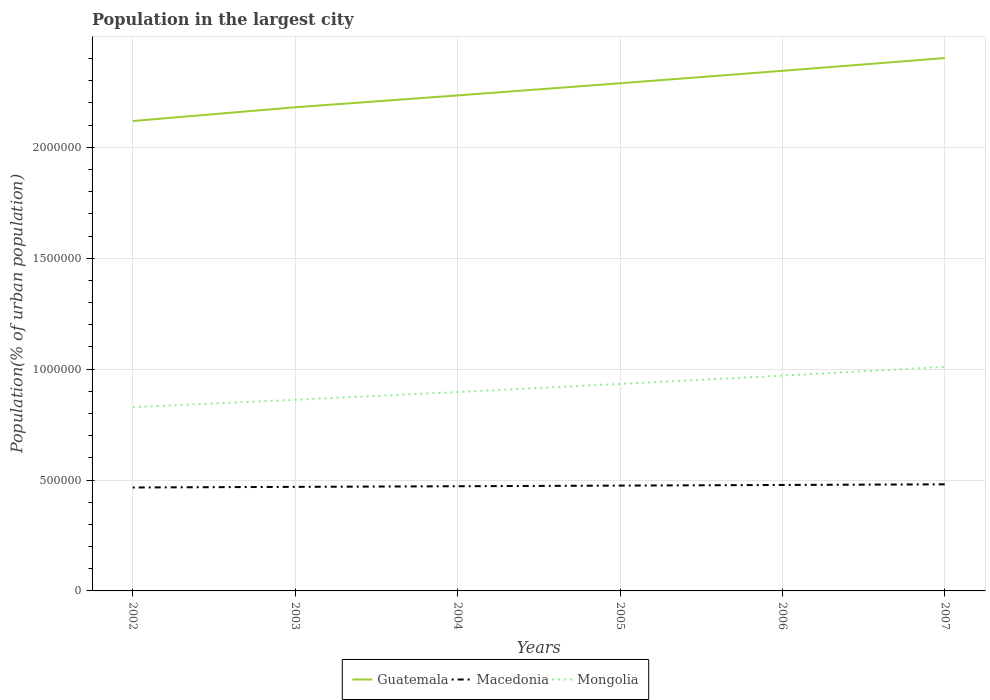Is the number of lines equal to the number of legend labels?
Your response must be concise. Yes. Across all years, what is the maximum population in the largest city in Mongolia?
Ensure brevity in your answer.  8.28e+05. In which year was the population in the largest city in Mongolia maximum?
Your response must be concise. 2002. What is the total population in the largest city in Mongolia in the graph?
Your response must be concise. -1.48e+05. What is the difference between the highest and the second highest population in the largest city in Guatemala?
Offer a terse response. 2.84e+05. What is the difference between the highest and the lowest population in the largest city in Mongolia?
Your answer should be compact. 3. Is the population in the largest city in Mongolia strictly greater than the population in the largest city in Macedonia over the years?
Give a very brief answer. No. How many years are there in the graph?
Your response must be concise. 6. What is the difference between two consecutive major ticks on the Y-axis?
Provide a succinct answer. 5.00e+05. Where does the legend appear in the graph?
Keep it short and to the point. Bottom center. What is the title of the graph?
Your response must be concise. Population in the largest city. What is the label or title of the X-axis?
Offer a terse response. Years. What is the label or title of the Y-axis?
Offer a very short reply. Population(% of urban population). What is the Population(% of urban population) in Guatemala in 2002?
Your response must be concise. 2.12e+06. What is the Population(% of urban population) in Macedonia in 2002?
Ensure brevity in your answer.  4.66e+05. What is the Population(% of urban population) in Mongolia in 2002?
Provide a short and direct response. 8.28e+05. What is the Population(% of urban population) in Guatemala in 2003?
Your answer should be very brief. 2.18e+06. What is the Population(% of urban population) of Macedonia in 2003?
Offer a terse response. 4.69e+05. What is the Population(% of urban population) in Mongolia in 2003?
Offer a very short reply. 8.62e+05. What is the Population(% of urban population) in Guatemala in 2004?
Your response must be concise. 2.23e+06. What is the Population(% of urban population) in Macedonia in 2004?
Give a very brief answer. 4.72e+05. What is the Population(% of urban population) in Mongolia in 2004?
Provide a short and direct response. 8.97e+05. What is the Population(% of urban population) in Guatemala in 2005?
Make the answer very short. 2.29e+06. What is the Population(% of urban population) of Macedonia in 2005?
Make the answer very short. 4.75e+05. What is the Population(% of urban population) of Mongolia in 2005?
Provide a short and direct response. 9.33e+05. What is the Population(% of urban population) of Guatemala in 2006?
Make the answer very short. 2.34e+06. What is the Population(% of urban population) in Macedonia in 2006?
Your response must be concise. 4.78e+05. What is the Population(% of urban population) in Mongolia in 2006?
Give a very brief answer. 9.71e+05. What is the Population(% of urban population) in Guatemala in 2007?
Provide a short and direct response. 2.40e+06. What is the Population(% of urban population) of Macedonia in 2007?
Make the answer very short. 4.81e+05. What is the Population(% of urban population) of Mongolia in 2007?
Keep it short and to the point. 1.01e+06. Across all years, what is the maximum Population(% of urban population) in Guatemala?
Offer a terse response. 2.40e+06. Across all years, what is the maximum Population(% of urban population) of Macedonia?
Your answer should be compact. 4.81e+05. Across all years, what is the maximum Population(% of urban population) of Mongolia?
Provide a succinct answer. 1.01e+06. Across all years, what is the minimum Population(% of urban population) in Guatemala?
Offer a very short reply. 2.12e+06. Across all years, what is the minimum Population(% of urban population) in Macedonia?
Your response must be concise. 4.66e+05. Across all years, what is the minimum Population(% of urban population) in Mongolia?
Keep it short and to the point. 8.28e+05. What is the total Population(% of urban population) of Guatemala in the graph?
Your answer should be very brief. 1.36e+07. What is the total Population(% of urban population) in Macedonia in the graph?
Offer a terse response. 2.84e+06. What is the total Population(% of urban population) of Mongolia in the graph?
Your answer should be very brief. 5.50e+06. What is the difference between the Population(% of urban population) in Guatemala in 2002 and that in 2003?
Provide a succinct answer. -6.19e+04. What is the difference between the Population(% of urban population) of Macedonia in 2002 and that in 2003?
Offer a very short reply. -2819. What is the difference between the Population(% of urban population) of Mongolia in 2002 and that in 2003?
Your answer should be compact. -3.35e+04. What is the difference between the Population(% of urban population) of Guatemala in 2002 and that in 2004?
Your answer should be very brief. -1.15e+05. What is the difference between the Population(% of urban population) of Macedonia in 2002 and that in 2004?
Offer a terse response. -5655. What is the difference between the Population(% of urban population) of Mongolia in 2002 and that in 2004?
Make the answer very short. -6.85e+04. What is the difference between the Population(% of urban population) of Guatemala in 2002 and that in 2005?
Your response must be concise. -1.70e+05. What is the difference between the Population(% of urban population) of Macedonia in 2002 and that in 2005?
Offer a terse response. -8508. What is the difference between the Population(% of urban population) in Mongolia in 2002 and that in 2005?
Your response must be concise. -1.05e+05. What is the difference between the Population(% of urban population) of Guatemala in 2002 and that in 2006?
Give a very brief answer. -2.26e+05. What is the difference between the Population(% of urban population) in Macedonia in 2002 and that in 2006?
Ensure brevity in your answer.  -1.14e+04. What is the difference between the Population(% of urban population) in Mongolia in 2002 and that in 2006?
Ensure brevity in your answer.  -1.43e+05. What is the difference between the Population(% of urban population) of Guatemala in 2002 and that in 2007?
Your answer should be very brief. -2.84e+05. What is the difference between the Population(% of urban population) in Macedonia in 2002 and that in 2007?
Your answer should be very brief. -1.43e+04. What is the difference between the Population(% of urban population) in Mongolia in 2002 and that in 2007?
Ensure brevity in your answer.  -1.82e+05. What is the difference between the Population(% of urban population) of Guatemala in 2003 and that in 2004?
Your answer should be very brief. -5.36e+04. What is the difference between the Population(% of urban population) of Macedonia in 2003 and that in 2004?
Make the answer very short. -2836. What is the difference between the Population(% of urban population) of Mongolia in 2003 and that in 2004?
Your response must be concise. -3.49e+04. What is the difference between the Population(% of urban population) of Guatemala in 2003 and that in 2005?
Keep it short and to the point. -1.08e+05. What is the difference between the Population(% of urban population) of Macedonia in 2003 and that in 2005?
Your answer should be compact. -5689. What is the difference between the Population(% of urban population) of Mongolia in 2003 and that in 2005?
Offer a very short reply. -7.12e+04. What is the difference between the Population(% of urban population) in Guatemala in 2003 and that in 2006?
Offer a very short reply. -1.64e+05. What is the difference between the Population(% of urban population) in Macedonia in 2003 and that in 2006?
Offer a terse response. -8560. What is the difference between the Population(% of urban population) in Mongolia in 2003 and that in 2006?
Provide a short and direct response. -1.09e+05. What is the difference between the Population(% of urban population) in Guatemala in 2003 and that in 2007?
Give a very brief answer. -2.22e+05. What is the difference between the Population(% of urban population) in Macedonia in 2003 and that in 2007?
Make the answer very short. -1.14e+04. What is the difference between the Population(% of urban population) in Mongolia in 2003 and that in 2007?
Offer a very short reply. -1.48e+05. What is the difference between the Population(% of urban population) of Guatemala in 2004 and that in 2005?
Give a very brief answer. -5.47e+04. What is the difference between the Population(% of urban population) in Macedonia in 2004 and that in 2005?
Provide a short and direct response. -2853. What is the difference between the Population(% of urban population) in Mongolia in 2004 and that in 2005?
Offer a terse response. -3.63e+04. What is the difference between the Population(% of urban population) of Guatemala in 2004 and that in 2006?
Your response must be concise. -1.11e+05. What is the difference between the Population(% of urban population) of Macedonia in 2004 and that in 2006?
Offer a very short reply. -5724. What is the difference between the Population(% of urban population) of Mongolia in 2004 and that in 2006?
Provide a short and direct response. -7.40e+04. What is the difference between the Population(% of urban population) in Guatemala in 2004 and that in 2007?
Offer a terse response. -1.68e+05. What is the difference between the Population(% of urban population) of Macedonia in 2004 and that in 2007?
Keep it short and to the point. -8611. What is the difference between the Population(% of urban population) of Mongolia in 2004 and that in 2007?
Ensure brevity in your answer.  -1.13e+05. What is the difference between the Population(% of urban population) in Guatemala in 2005 and that in 2006?
Your answer should be very brief. -5.62e+04. What is the difference between the Population(% of urban population) in Macedonia in 2005 and that in 2006?
Provide a succinct answer. -2871. What is the difference between the Population(% of urban population) of Mongolia in 2005 and that in 2006?
Provide a succinct answer. -3.78e+04. What is the difference between the Population(% of urban population) of Guatemala in 2005 and that in 2007?
Provide a short and direct response. -1.14e+05. What is the difference between the Population(% of urban population) in Macedonia in 2005 and that in 2007?
Provide a succinct answer. -5758. What is the difference between the Population(% of urban population) of Mongolia in 2005 and that in 2007?
Provide a short and direct response. -7.71e+04. What is the difference between the Population(% of urban population) in Guatemala in 2006 and that in 2007?
Keep it short and to the point. -5.75e+04. What is the difference between the Population(% of urban population) in Macedonia in 2006 and that in 2007?
Keep it short and to the point. -2887. What is the difference between the Population(% of urban population) in Mongolia in 2006 and that in 2007?
Provide a succinct answer. -3.93e+04. What is the difference between the Population(% of urban population) of Guatemala in 2002 and the Population(% of urban population) of Macedonia in 2003?
Provide a succinct answer. 1.65e+06. What is the difference between the Population(% of urban population) in Guatemala in 2002 and the Population(% of urban population) in Mongolia in 2003?
Provide a succinct answer. 1.26e+06. What is the difference between the Population(% of urban population) of Macedonia in 2002 and the Population(% of urban population) of Mongolia in 2003?
Keep it short and to the point. -3.95e+05. What is the difference between the Population(% of urban population) in Guatemala in 2002 and the Population(% of urban population) in Macedonia in 2004?
Your response must be concise. 1.65e+06. What is the difference between the Population(% of urban population) in Guatemala in 2002 and the Population(% of urban population) in Mongolia in 2004?
Offer a very short reply. 1.22e+06. What is the difference between the Population(% of urban population) of Macedonia in 2002 and the Population(% of urban population) of Mongolia in 2004?
Your response must be concise. -4.30e+05. What is the difference between the Population(% of urban population) in Guatemala in 2002 and the Population(% of urban population) in Macedonia in 2005?
Give a very brief answer. 1.64e+06. What is the difference between the Population(% of urban population) of Guatemala in 2002 and the Population(% of urban population) of Mongolia in 2005?
Keep it short and to the point. 1.19e+06. What is the difference between the Population(% of urban population) of Macedonia in 2002 and the Population(% of urban population) of Mongolia in 2005?
Provide a succinct answer. -4.67e+05. What is the difference between the Population(% of urban population) of Guatemala in 2002 and the Population(% of urban population) of Macedonia in 2006?
Ensure brevity in your answer.  1.64e+06. What is the difference between the Population(% of urban population) of Guatemala in 2002 and the Population(% of urban population) of Mongolia in 2006?
Provide a short and direct response. 1.15e+06. What is the difference between the Population(% of urban population) in Macedonia in 2002 and the Population(% of urban population) in Mongolia in 2006?
Make the answer very short. -5.04e+05. What is the difference between the Population(% of urban population) of Guatemala in 2002 and the Population(% of urban population) of Macedonia in 2007?
Your response must be concise. 1.64e+06. What is the difference between the Population(% of urban population) in Guatemala in 2002 and the Population(% of urban population) in Mongolia in 2007?
Your answer should be very brief. 1.11e+06. What is the difference between the Population(% of urban population) in Macedonia in 2002 and the Population(% of urban population) in Mongolia in 2007?
Ensure brevity in your answer.  -5.44e+05. What is the difference between the Population(% of urban population) of Guatemala in 2003 and the Population(% of urban population) of Macedonia in 2004?
Provide a short and direct response. 1.71e+06. What is the difference between the Population(% of urban population) of Guatemala in 2003 and the Population(% of urban population) of Mongolia in 2004?
Provide a short and direct response. 1.28e+06. What is the difference between the Population(% of urban population) of Macedonia in 2003 and the Population(% of urban population) of Mongolia in 2004?
Keep it short and to the point. -4.28e+05. What is the difference between the Population(% of urban population) in Guatemala in 2003 and the Population(% of urban population) in Macedonia in 2005?
Give a very brief answer. 1.71e+06. What is the difference between the Population(% of urban population) of Guatemala in 2003 and the Population(% of urban population) of Mongolia in 2005?
Your answer should be very brief. 1.25e+06. What is the difference between the Population(% of urban population) of Macedonia in 2003 and the Population(% of urban population) of Mongolia in 2005?
Keep it short and to the point. -4.64e+05. What is the difference between the Population(% of urban population) in Guatemala in 2003 and the Population(% of urban population) in Macedonia in 2006?
Offer a very short reply. 1.70e+06. What is the difference between the Population(% of urban population) in Guatemala in 2003 and the Population(% of urban population) in Mongolia in 2006?
Offer a very short reply. 1.21e+06. What is the difference between the Population(% of urban population) in Macedonia in 2003 and the Population(% of urban population) in Mongolia in 2006?
Your answer should be very brief. -5.02e+05. What is the difference between the Population(% of urban population) in Guatemala in 2003 and the Population(% of urban population) in Macedonia in 2007?
Your answer should be compact. 1.70e+06. What is the difference between the Population(% of urban population) of Guatemala in 2003 and the Population(% of urban population) of Mongolia in 2007?
Ensure brevity in your answer.  1.17e+06. What is the difference between the Population(% of urban population) in Macedonia in 2003 and the Population(% of urban population) in Mongolia in 2007?
Ensure brevity in your answer.  -5.41e+05. What is the difference between the Population(% of urban population) in Guatemala in 2004 and the Population(% of urban population) in Macedonia in 2005?
Keep it short and to the point. 1.76e+06. What is the difference between the Population(% of urban population) in Guatemala in 2004 and the Population(% of urban population) in Mongolia in 2005?
Provide a short and direct response. 1.30e+06. What is the difference between the Population(% of urban population) of Macedonia in 2004 and the Population(% of urban population) of Mongolia in 2005?
Provide a succinct answer. -4.61e+05. What is the difference between the Population(% of urban population) in Guatemala in 2004 and the Population(% of urban population) in Macedonia in 2006?
Your answer should be very brief. 1.76e+06. What is the difference between the Population(% of urban population) of Guatemala in 2004 and the Population(% of urban population) of Mongolia in 2006?
Make the answer very short. 1.26e+06. What is the difference between the Population(% of urban population) in Macedonia in 2004 and the Population(% of urban population) in Mongolia in 2006?
Provide a short and direct response. -4.99e+05. What is the difference between the Population(% of urban population) of Guatemala in 2004 and the Population(% of urban population) of Macedonia in 2007?
Ensure brevity in your answer.  1.75e+06. What is the difference between the Population(% of urban population) in Guatemala in 2004 and the Population(% of urban population) in Mongolia in 2007?
Offer a very short reply. 1.22e+06. What is the difference between the Population(% of urban population) in Macedonia in 2004 and the Population(% of urban population) in Mongolia in 2007?
Your answer should be compact. -5.38e+05. What is the difference between the Population(% of urban population) of Guatemala in 2005 and the Population(% of urban population) of Macedonia in 2006?
Keep it short and to the point. 1.81e+06. What is the difference between the Population(% of urban population) in Guatemala in 2005 and the Population(% of urban population) in Mongolia in 2006?
Your answer should be compact. 1.32e+06. What is the difference between the Population(% of urban population) in Macedonia in 2005 and the Population(% of urban population) in Mongolia in 2006?
Give a very brief answer. -4.96e+05. What is the difference between the Population(% of urban population) in Guatemala in 2005 and the Population(% of urban population) in Macedonia in 2007?
Make the answer very short. 1.81e+06. What is the difference between the Population(% of urban population) of Guatemala in 2005 and the Population(% of urban population) of Mongolia in 2007?
Your response must be concise. 1.28e+06. What is the difference between the Population(% of urban population) in Macedonia in 2005 and the Population(% of urban population) in Mongolia in 2007?
Keep it short and to the point. -5.35e+05. What is the difference between the Population(% of urban population) of Guatemala in 2006 and the Population(% of urban population) of Macedonia in 2007?
Your response must be concise. 1.86e+06. What is the difference between the Population(% of urban population) of Guatemala in 2006 and the Population(% of urban population) of Mongolia in 2007?
Your answer should be compact. 1.33e+06. What is the difference between the Population(% of urban population) in Macedonia in 2006 and the Population(% of urban population) in Mongolia in 2007?
Give a very brief answer. -5.32e+05. What is the average Population(% of urban population) of Guatemala per year?
Provide a short and direct response. 2.26e+06. What is the average Population(% of urban population) in Macedonia per year?
Your response must be concise. 4.73e+05. What is the average Population(% of urban population) of Mongolia per year?
Your answer should be compact. 9.17e+05. In the year 2002, what is the difference between the Population(% of urban population) of Guatemala and Population(% of urban population) of Macedonia?
Your answer should be very brief. 1.65e+06. In the year 2002, what is the difference between the Population(% of urban population) of Guatemala and Population(% of urban population) of Mongolia?
Offer a terse response. 1.29e+06. In the year 2002, what is the difference between the Population(% of urban population) of Macedonia and Population(% of urban population) of Mongolia?
Offer a very short reply. -3.62e+05. In the year 2003, what is the difference between the Population(% of urban population) in Guatemala and Population(% of urban population) in Macedonia?
Ensure brevity in your answer.  1.71e+06. In the year 2003, what is the difference between the Population(% of urban population) of Guatemala and Population(% of urban population) of Mongolia?
Give a very brief answer. 1.32e+06. In the year 2003, what is the difference between the Population(% of urban population) in Macedonia and Population(% of urban population) in Mongolia?
Offer a very short reply. -3.93e+05. In the year 2004, what is the difference between the Population(% of urban population) in Guatemala and Population(% of urban population) in Macedonia?
Ensure brevity in your answer.  1.76e+06. In the year 2004, what is the difference between the Population(% of urban population) in Guatemala and Population(% of urban population) in Mongolia?
Give a very brief answer. 1.34e+06. In the year 2004, what is the difference between the Population(% of urban population) in Macedonia and Population(% of urban population) in Mongolia?
Make the answer very short. -4.25e+05. In the year 2005, what is the difference between the Population(% of urban population) of Guatemala and Population(% of urban population) of Macedonia?
Offer a very short reply. 1.81e+06. In the year 2005, what is the difference between the Population(% of urban population) in Guatemala and Population(% of urban population) in Mongolia?
Provide a short and direct response. 1.36e+06. In the year 2005, what is the difference between the Population(% of urban population) in Macedonia and Population(% of urban population) in Mongolia?
Offer a very short reply. -4.58e+05. In the year 2006, what is the difference between the Population(% of urban population) in Guatemala and Population(% of urban population) in Macedonia?
Your answer should be compact. 1.87e+06. In the year 2006, what is the difference between the Population(% of urban population) of Guatemala and Population(% of urban population) of Mongolia?
Give a very brief answer. 1.37e+06. In the year 2006, what is the difference between the Population(% of urban population) in Macedonia and Population(% of urban population) in Mongolia?
Ensure brevity in your answer.  -4.93e+05. In the year 2007, what is the difference between the Population(% of urban population) of Guatemala and Population(% of urban population) of Macedonia?
Give a very brief answer. 1.92e+06. In the year 2007, what is the difference between the Population(% of urban population) of Guatemala and Population(% of urban population) of Mongolia?
Give a very brief answer. 1.39e+06. In the year 2007, what is the difference between the Population(% of urban population) of Macedonia and Population(% of urban population) of Mongolia?
Provide a succinct answer. -5.30e+05. What is the ratio of the Population(% of urban population) in Guatemala in 2002 to that in 2003?
Your answer should be very brief. 0.97. What is the ratio of the Population(% of urban population) of Macedonia in 2002 to that in 2003?
Offer a terse response. 0.99. What is the ratio of the Population(% of urban population) of Mongolia in 2002 to that in 2003?
Provide a short and direct response. 0.96. What is the ratio of the Population(% of urban population) in Guatemala in 2002 to that in 2004?
Your response must be concise. 0.95. What is the ratio of the Population(% of urban population) in Macedonia in 2002 to that in 2004?
Your answer should be compact. 0.99. What is the ratio of the Population(% of urban population) of Mongolia in 2002 to that in 2004?
Keep it short and to the point. 0.92. What is the ratio of the Population(% of urban population) of Guatemala in 2002 to that in 2005?
Offer a terse response. 0.93. What is the ratio of the Population(% of urban population) in Macedonia in 2002 to that in 2005?
Offer a terse response. 0.98. What is the ratio of the Population(% of urban population) of Mongolia in 2002 to that in 2005?
Provide a succinct answer. 0.89. What is the ratio of the Population(% of urban population) in Guatemala in 2002 to that in 2006?
Provide a short and direct response. 0.9. What is the ratio of the Population(% of urban population) of Macedonia in 2002 to that in 2006?
Ensure brevity in your answer.  0.98. What is the ratio of the Population(% of urban population) in Mongolia in 2002 to that in 2006?
Your answer should be compact. 0.85. What is the ratio of the Population(% of urban population) of Guatemala in 2002 to that in 2007?
Offer a very short reply. 0.88. What is the ratio of the Population(% of urban population) of Macedonia in 2002 to that in 2007?
Give a very brief answer. 0.97. What is the ratio of the Population(% of urban population) of Mongolia in 2002 to that in 2007?
Provide a succinct answer. 0.82. What is the ratio of the Population(% of urban population) in Guatemala in 2003 to that in 2004?
Offer a very short reply. 0.98. What is the ratio of the Population(% of urban population) of Mongolia in 2003 to that in 2004?
Your response must be concise. 0.96. What is the ratio of the Population(% of urban population) in Guatemala in 2003 to that in 2005?
Provide a short and direct response. 0.95. What is the ratio of the Population(% of urban population) of Mongolia in 2003 to that in 2005?
Offer a terse response. 0.92. What is the ratio of the Population(% of urban population) in Guatemala in 2003 to that in 2006?
Offer a terse response. 0.93. What is the ratio of the Population(% of urban population) in Macedonia in 2003 to that in 2006?
Offer a very short reply. 0.98. What is the ratio of the Population(% of urban population) of Mongolia in 2003 to that in 2006?
Offer a very short reply. 0.89. What is the ratio of the Population(% of urban population) of Guatemala in 2003 to that in 2007?
Offer a terse response. 0.91. What is the ratio of the Population(% of urban population) of Macedonia in 2003 to that in 2007?
Give a very brief answer. 0.98. What is the ratio of the Population(% of urban population) in Mongolia in 2003 to that in 2007?
Offer a very short reply. 0.85. What is the ratio of the Population(% of urban population) of Guatemala in 2004 to that in 2005?
Keep it short and to the point. 0.98. What is the ratio of the Population(% of urban population) of Mongolia in 2004 to that in 2005?
Your answer should be very brief. 0.96. What is the ratio of the Population(% of urban population) of Guatemala in 2004 to that in 2006?
Your answer should be very brief. 0.95. What is the ratio of the Population(% of urban population) of Mongolia in 2004 to that in 2006?
Make the answer very short. 0.92. What is the ratio of the Population(% of urban population) in Guatemala in 2004 to that in 2007?
Provide a short and direct response. 0.93. What is the ratio of the Population(% of urban population) in Macedonia in 2004 to that in 2007?
Your answer should be very brief. 0.98. What is the ratio of the Population(% of urban population) of Mongolia in 2004 to that in 2007?
Your response must be concise. 0.89. What is the ratio of the Population(% of urban population) in Guatemala in 2005 to that in 2006?
Ensure brevity in your answer.  0.98. What is the ratio of the Population(% of urban population) of Macedonia in 2005 to that in 2006?
Provide a short and direct response. 0.99. What is the ratio of the Population(% of urban population) of Mongolia in 2005 to that in 2006?
Keep it short and to the point. 0.96. What is the ratio of the Population(% of urban population) in Guatemala in 2005 to that in 2007?
Keep it short and to the point. 0.95. What is the ratio of the Population(% of urban population) of Macedonia in 2005 to that in 2007?
Provide a short and direct response. 0.99. What is the ratio of the Population(% of urban population) of Mongolia in 2005 to that in 2007?
Offer a very short reply. 0.92. What is the ratio of the Population(% of urban population) of Guatemala in 2006 to that in 2007?
Give a very brief answer. 0.98. What is the ratio of the Population(% of urban population) of Macedonia in 2006 to that in 2007?
Make the answer very short. 0.99. What is the ratio of the Population(% of urban population) of Mongolia in 2006 to that in 2007?
Provide a succinct answer. 0.96. What is the difference between the highest and the second highest Population(% of urban population) of Guatemala?
Provide a short and direct response. 5.75e+04. What is the difference between the highest and the second highest Population(% of urban population) in Macedonia?
Your response must be concise. 2887. What is the difference between the highest and the second highest Population(% of urban population) in Mongolia?
Your response must be concise. 3.93e+04. What is the difference between the highest and the lowest Population(% of urban population) in Guatemala?
Your answer should be compact. 2.84e+05. What is the difference between the highest and the lowest Population(% of urban population) in Macedonia?
Keep it short and to the point. 1.43e+04. What is the difference between the highest and the lowest Population(% of urban population) of Mongolia?
Offer a very short reply. 1.82e+05. 